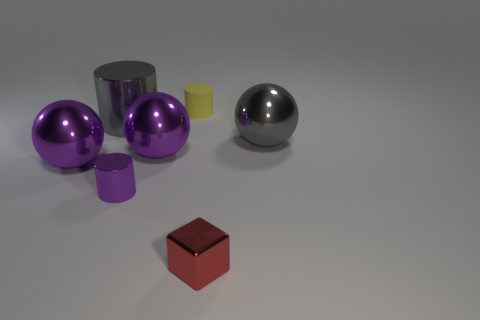Add 1 tiny rubber objects. How many objects exist? 8 Subtract all cylinders. How many objects are left? 4 Add 6 large gray shiny spheres. How many large gray shiny spheres are left? 7 Add 1 tiny purple things. How many tiny purple things exist? 2 Subtract 0 blue spheres. How many objects are left? 7 Subtract all matte things. Subtract all small yellow objects. How many objects are left? 5 